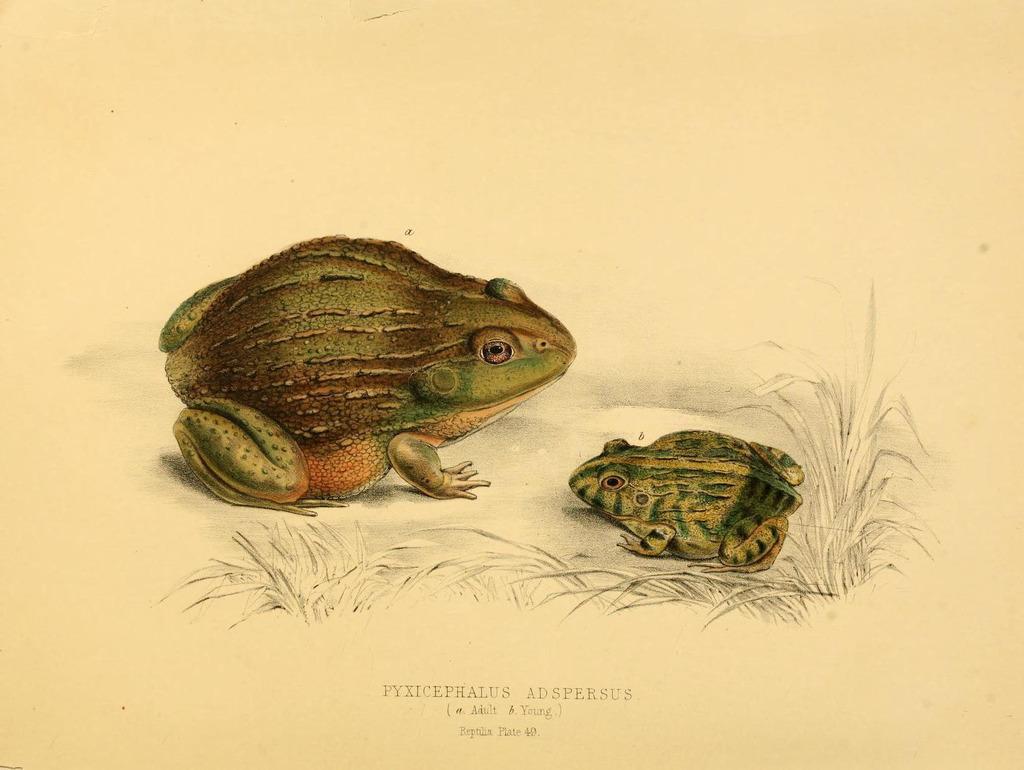Could you give a brief overview of what you see in this image? In this image in the middle, there are two frogs. At the bottom there are plants and text. 